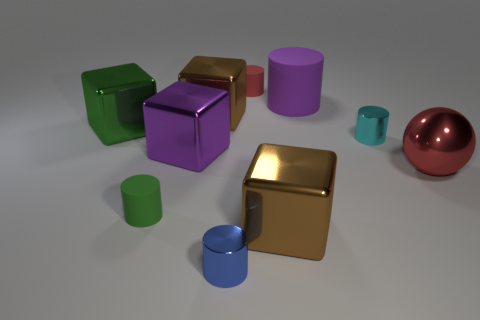Subtract all green rubber cylinders. How many cylinders are left? 4 Subtract all gray cylinders. Subtract all yellow cubes. How many cylinders are left? 5 Subtract all balls. How many objects are left? 9 Subtract 0 purple balls. How many objects are left? 10 Subtract all large blue metal cylinders. Subtract all small red cylinders. How many objects are left? 9 Add 2 tiny red things. How many tiny red things are left? 3 Add 6 small cyan shiny cylinders. How many small cyan shiny cylinders exist? 7 